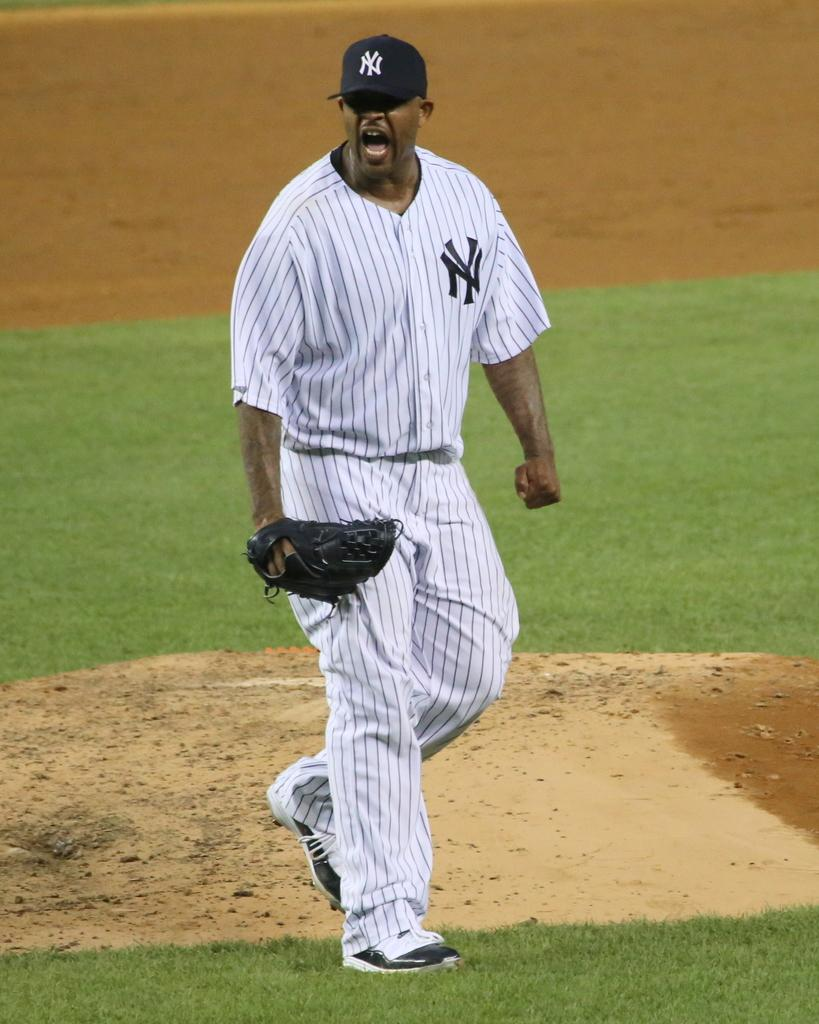<image>
Present a compact description of the photo's key features. The pitcher for the New York Yankees celebrates after striking out a batter to end the inning. 